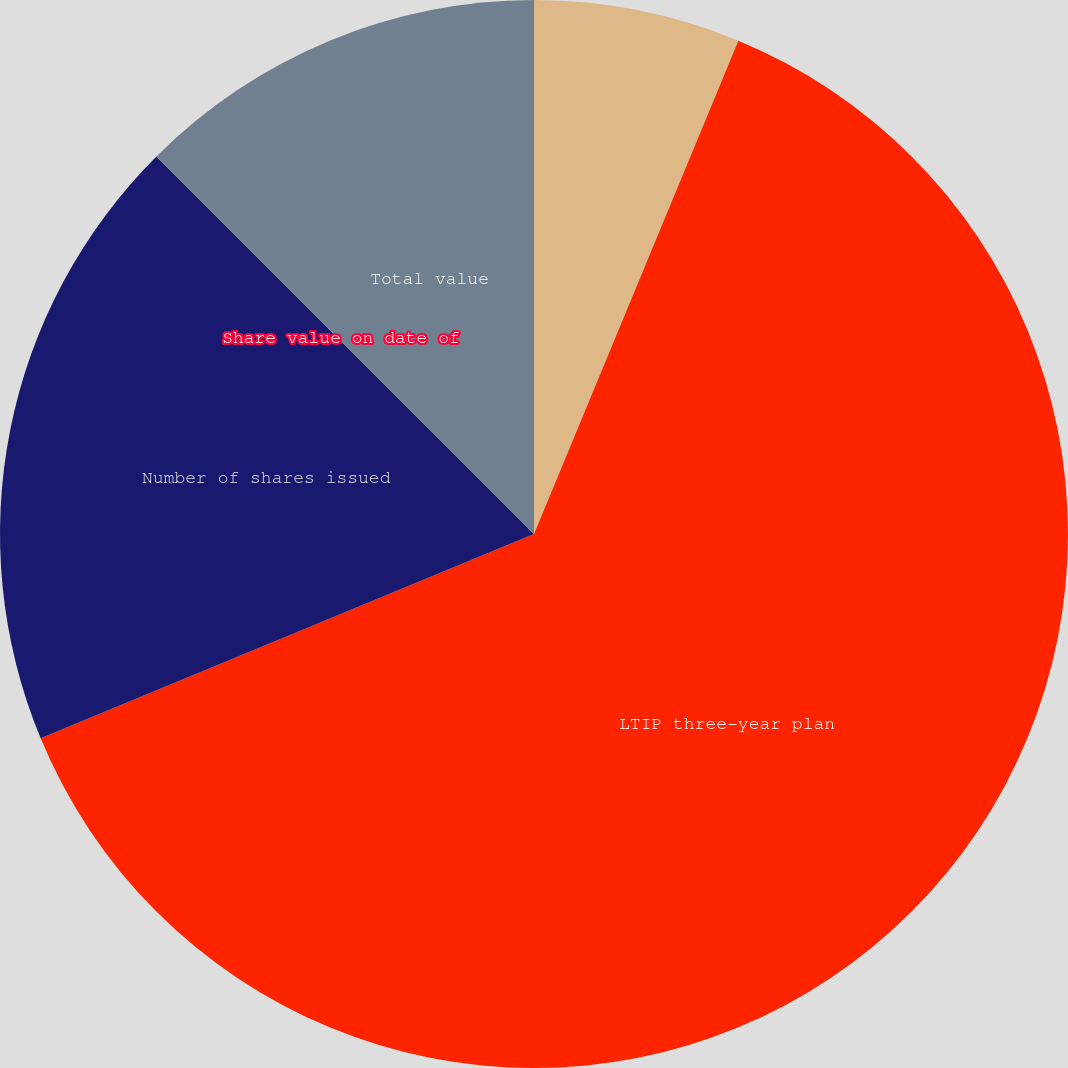Convert chart. <chart><loc_0><loc_0><loc_500><loc_500><pie_chart><fcel>Stock issued for LTIP<fcel>LTIP three-year plan<fcel>Number of shares issued<fcel>Share value on date of<fcel>Total value<nl><fcel>6.25%<fcel>62.5%<fcel>18.75%<fcel>0.0%<fcel>12.5%<nl></chart> 